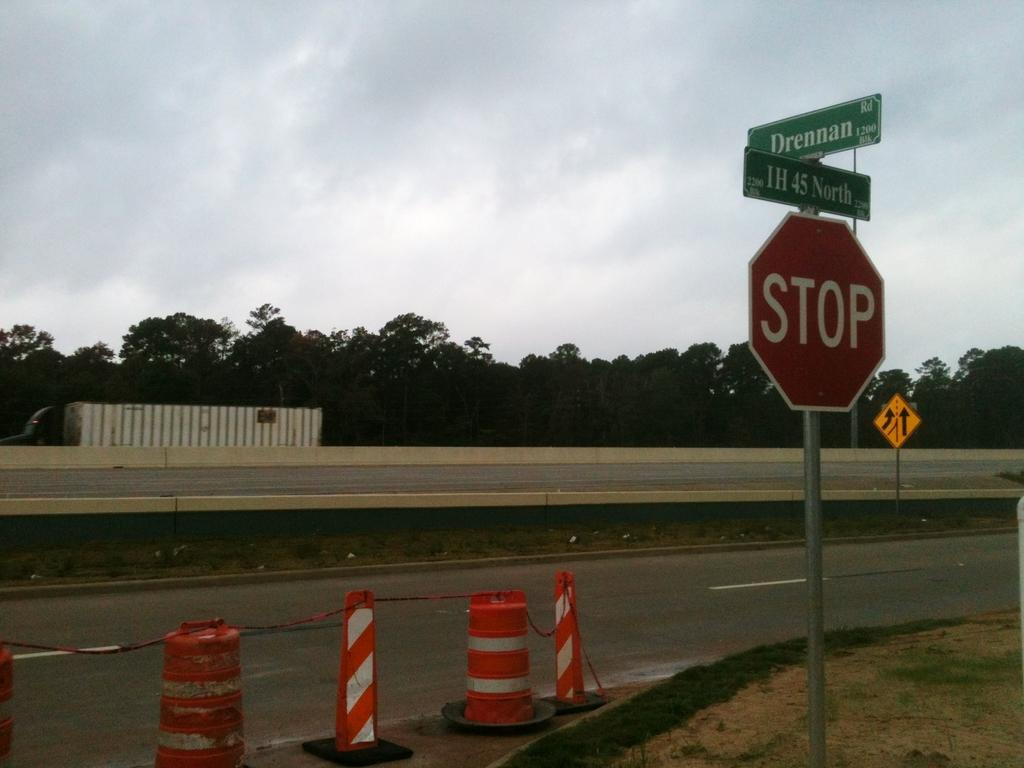<image>
Render a clear and concise summary of the photo. A stop sign is below the street signs next to orange traffic cones. 